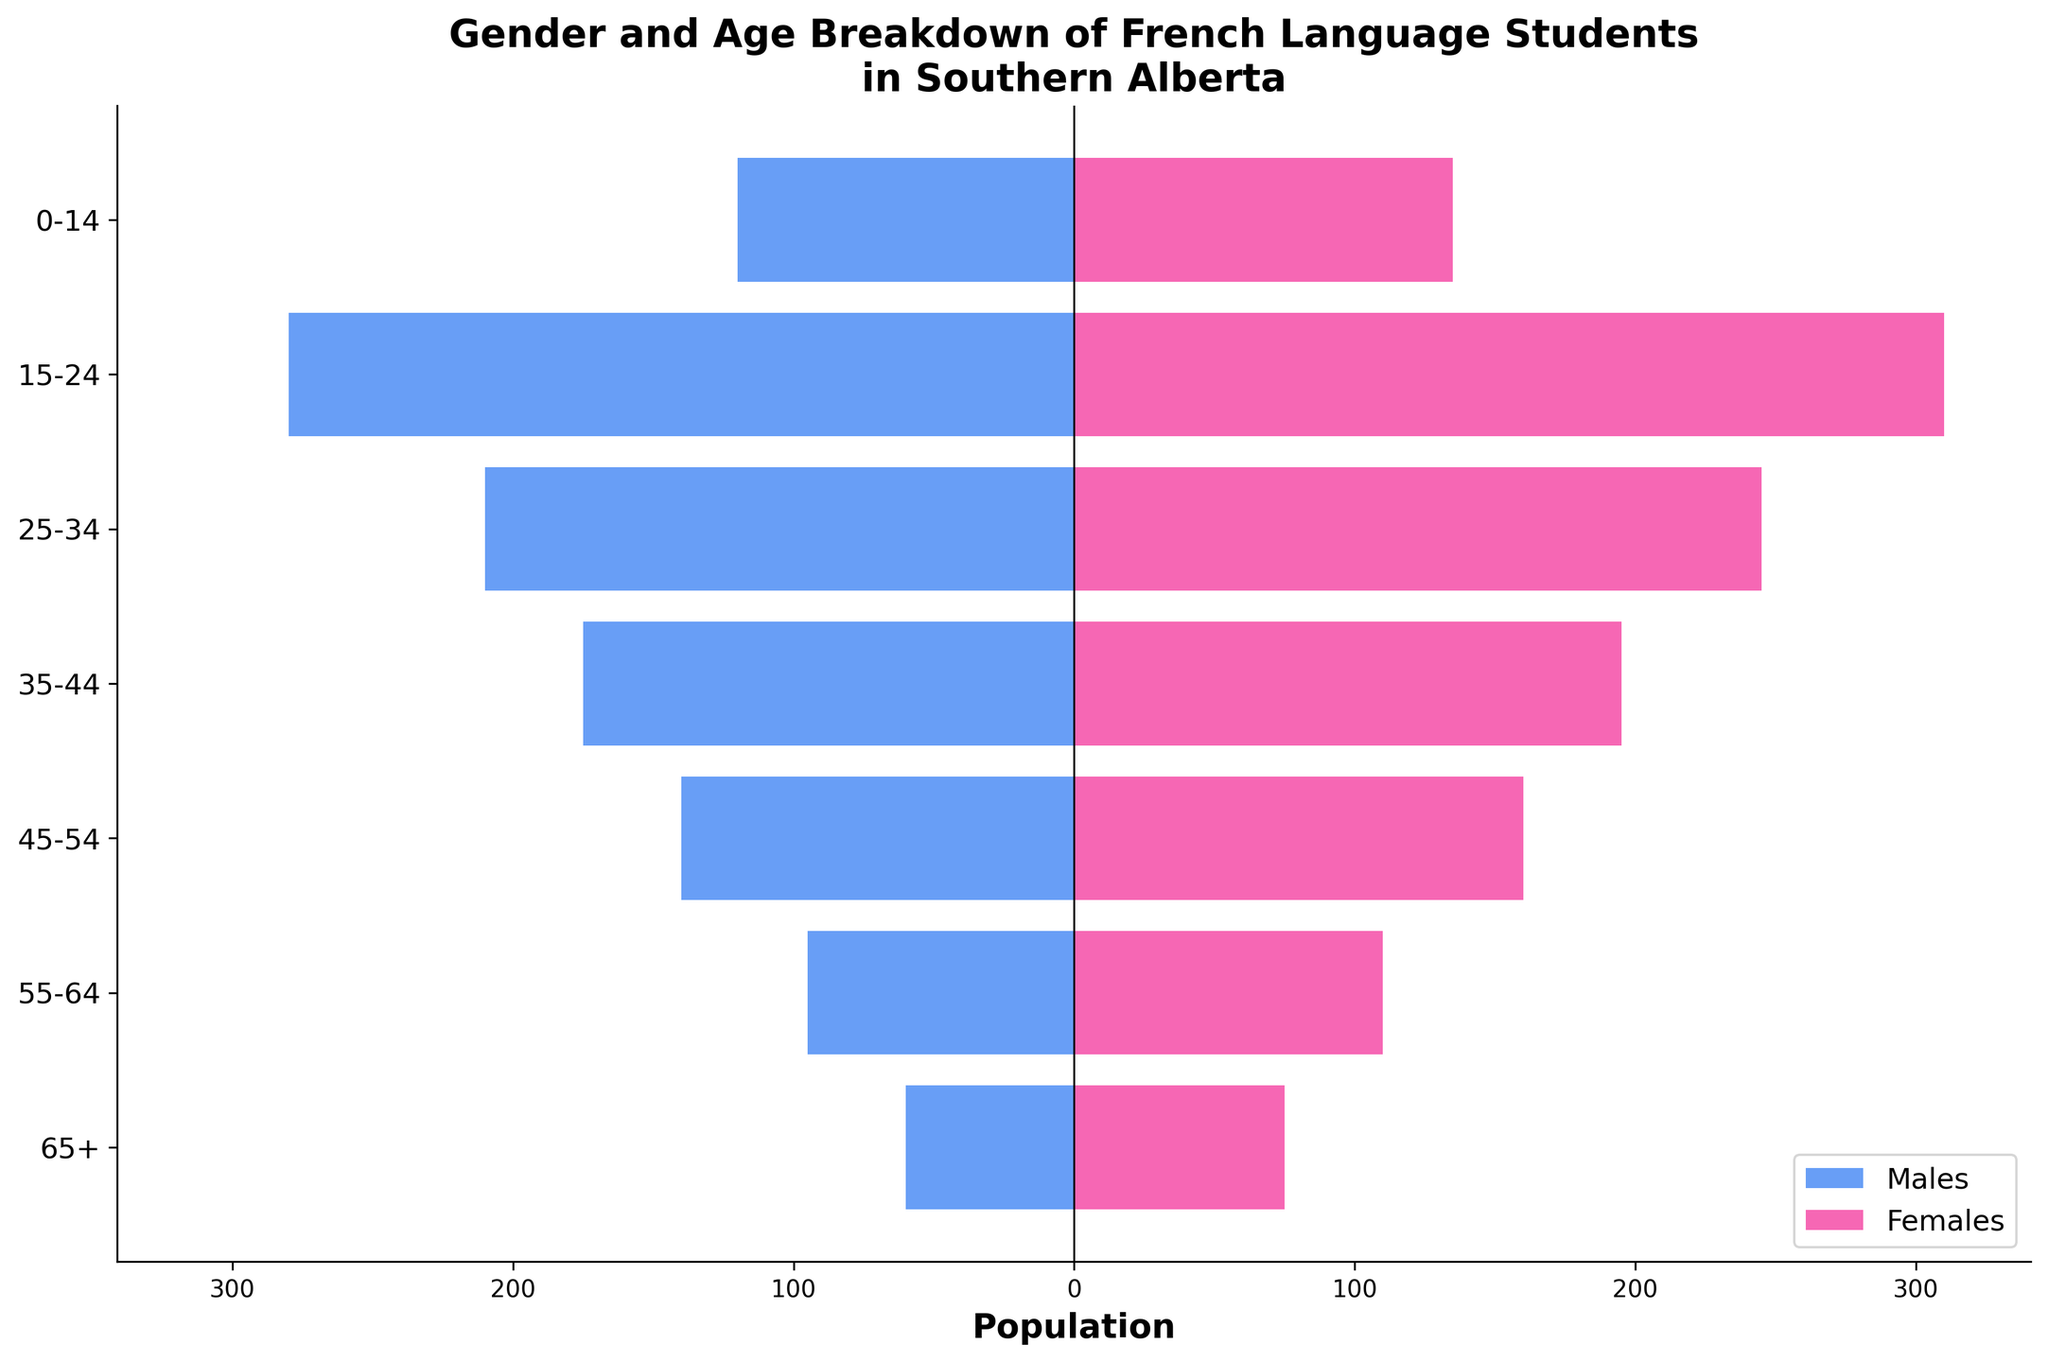What is the title of the figure? The title of the figure is displayed at the top and usually gives a summary of what the figure is showing. In this case, it depicts the population breakdown of French language students in Southern Alberta by gender and age.
Answer: Gender and Age Breakdown of French Language Students in Southern Alberta What is the age group with the highest number of female students? Look at the pink bars representing females and identify which age group has the longest bar.
Answer: 15-24 How many male students are in the 45-54 age group? Refer to the blue bar for the 45-54 age group and read the value labeled on it.
Answer: 140 Which gender has more students in the 35-44 age group? Compare the lengths of the blue (males) and pink (females) bars for the 35-44 age group to see which one is longer.
Answer: Females What is the total number of students aged 0-14? Sum the number of male and female students in the 0-14 age group. 120 (males) + 135 (females) = 255.
Answer: 255 Which age group has the smallest population of male students? Identify the blue bar with the lowest value.
Answer: 65+ What is the overall population difference between males and females aged 15-24? Subtract the number of male students from the number of female students in the 15-24 age group. 310 (females) - 280 (males) = 30.
Answer: 30 How many more students are there in the 25-34 age group compared to the 55-64 age group? Calculate the sum of students in each age group and find the difference. (210 males + 245 females) - (95 males + 110 females) = 455 - 205 = 250.
Answer: 250 What percentage of the total students are aged 65+? First, calculate the total number of students. Then determine the number of students aged 65+ and divide by the total. Multiply by 100 to get the percentage. Total students = 1280; students aged 65+ = 135; percentage = (135 / 1280) * 100 ≈ 10.55%.
Answer: ≈ 10.55% Are there more male students or female students overall? Calculate the total number of male and female students and compare. Total males = 1080; total females = 1200; thus, females are more.
Answer: Female students 